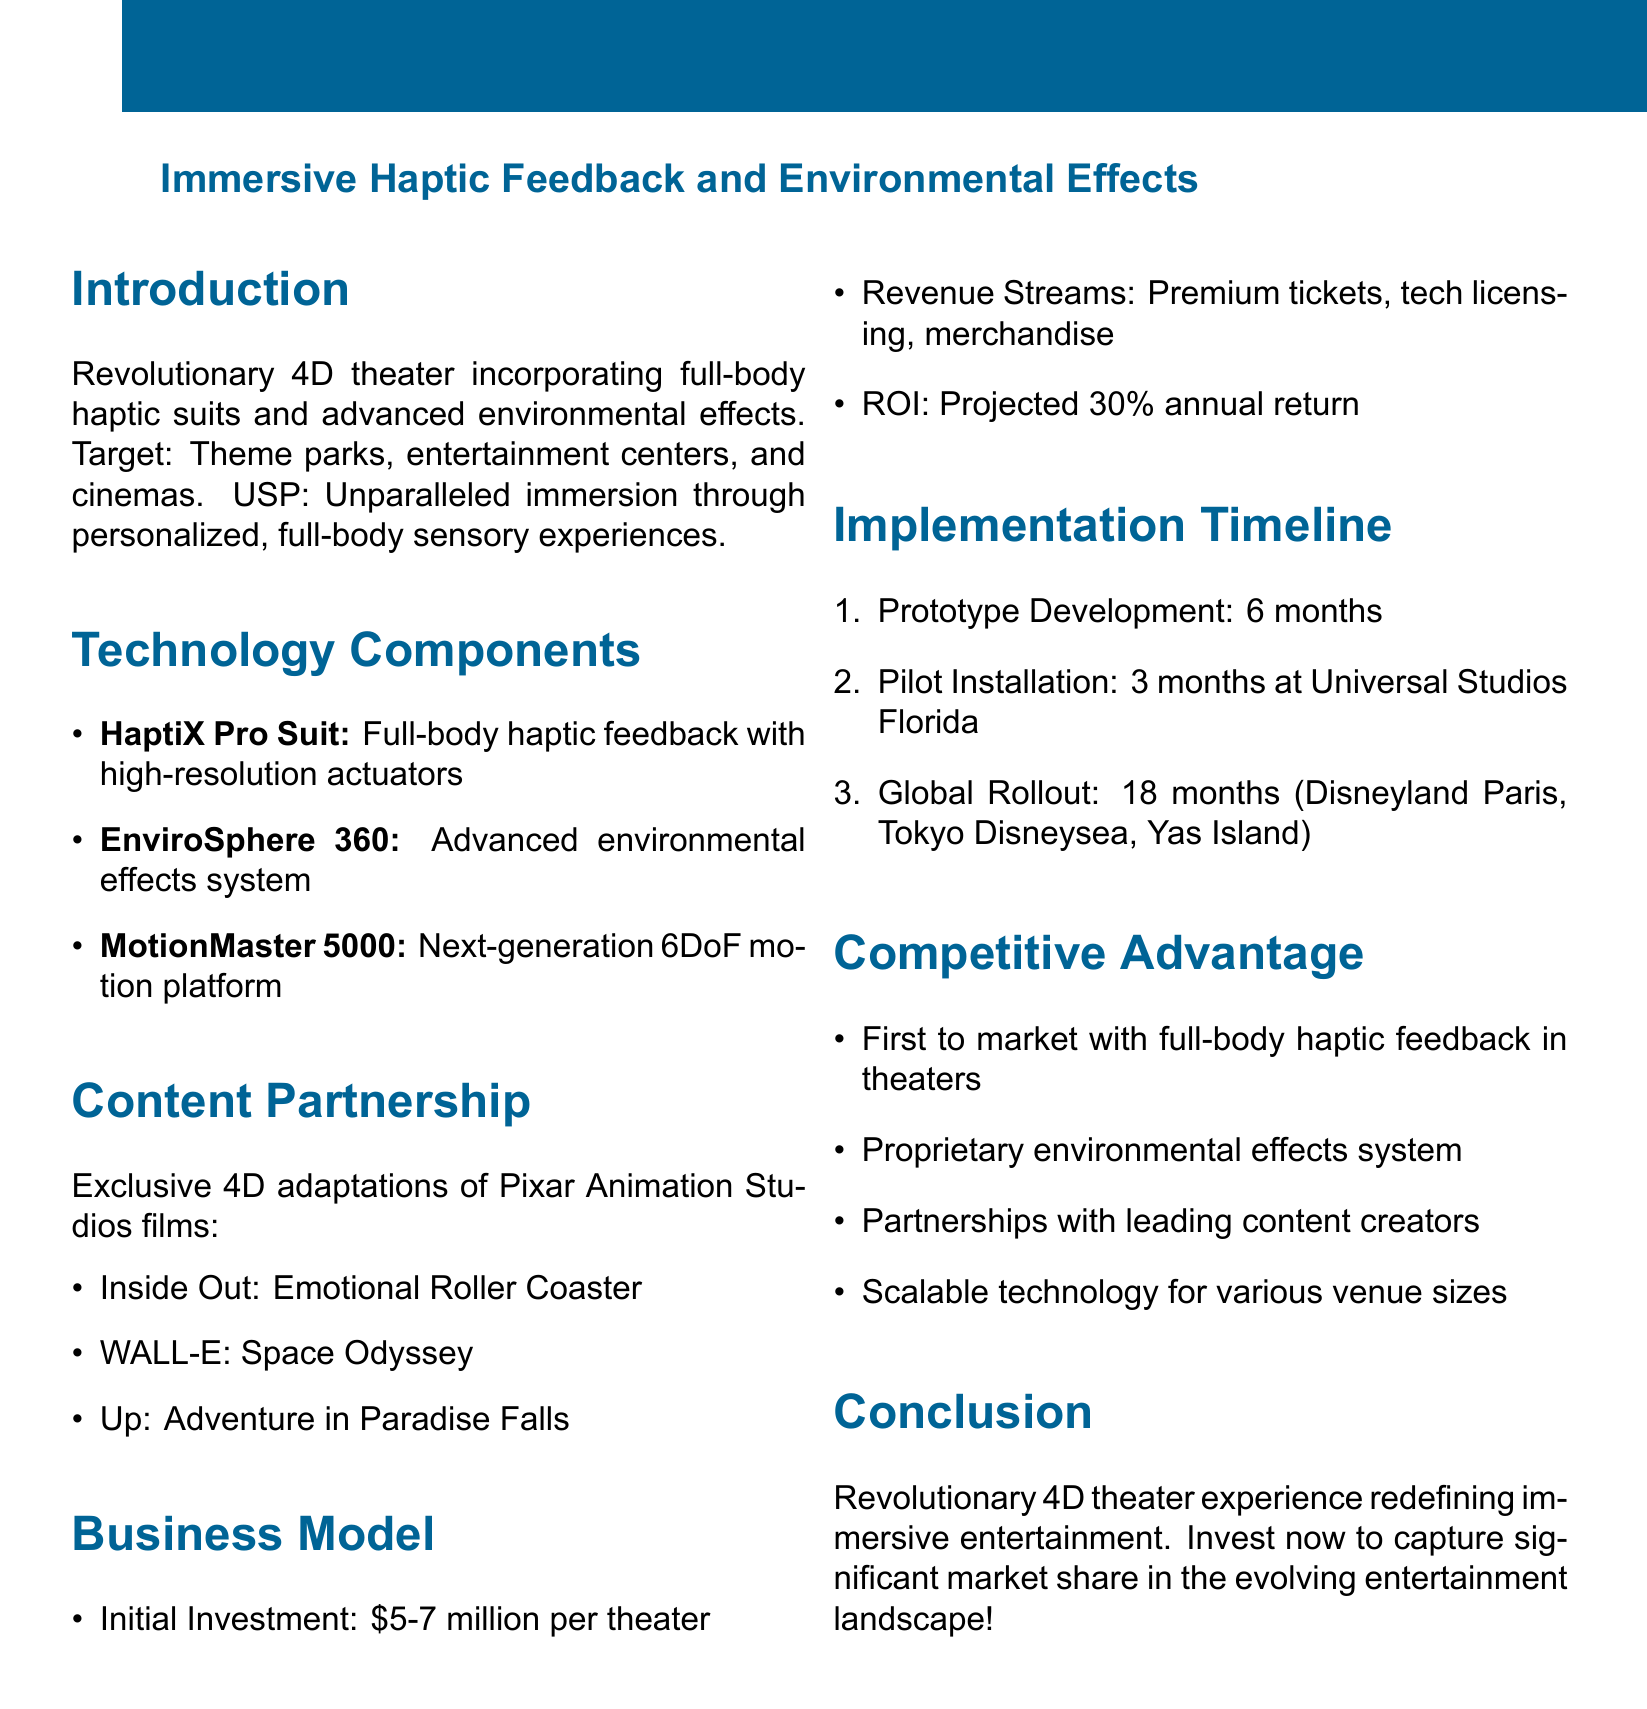What is the target audience for the 4D theater experience? The target audience is specified as theme parks, entertainment centers, and cinemas seeking cutting-edge attractions.
Answer: Theme parks, entertainment centers, and cinemas What is the projected ROI for the investment? The document states that the projected return on investment is estimated from the business model section.
Answer: 30% annual return What are the features of the HaptiX Pro Suit? The document lists several features of the HaptiX Pro Suit, including specific types of feedback and controls.
Answer: Precise vibration and pressure feedback, Temperature control, Lightweight and adjustable What is the duration of the prototype development phase? This information is provided in the implementation timeline section detailing project phases.
Answer: 6 months How many distinct aromas can the scent diffusion system create? The document specifies the capacity of the scent diffusion system within the EnviroSphere 360 component.
Answer: 100+ distinct aromas Which studio is the content partner for this project? The memo mentions a specific partnership crucial for content offerings in the theater experience.
Answer: Pixar Animation Studios In which location will the pilot installation take place? The pilot installation location is clearly indicated in the implementation timeline section of the memo.
Answer: Universal Studios Florida What is the initial investment required per theater? The document provides a specific financial figure in the business model section concerning the start-up costs.
Answer: $5-7 million per theater What advantages does this theater experience have over competitors? The competitive advantage section outlines the unique features that set this concept apart in the market.
Answer: First to market with full-body haptic feedback in theater setting, Proprietary environmental effects system 